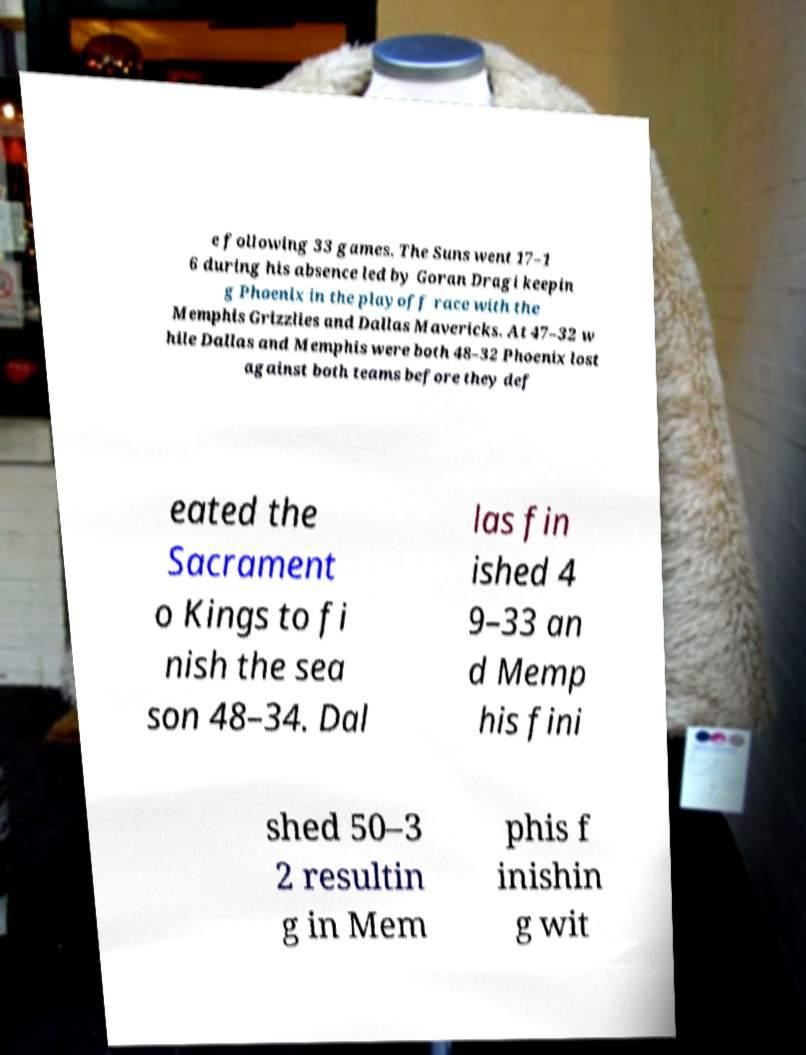For documentation purposes, I need the text within this image transcribed. Could you provide that? e following 33 games. The Suns went 17–1 6 during his absence led by Goran Dragi keepin g Phoenix in the playoff race with the Memphis Grizzlies and Dallas Mavericks. At 47–32 w hile Dallas and Memphis were both 48–32 Phoenix lost against both teams before they def eated the Sacrament o Kings to fi nish the sea son 48–34. Dal las fin ished 4 9–33 an d Memp his fini shed 50–3 2 resultin g in Mem phis f inishin g wit 